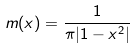<formula> <loc_0><loc_0><loc_500><loc_500>m ( x ) = \frac { 1 } { \pi | 1 - x ^ { 2 } | }</formula> 